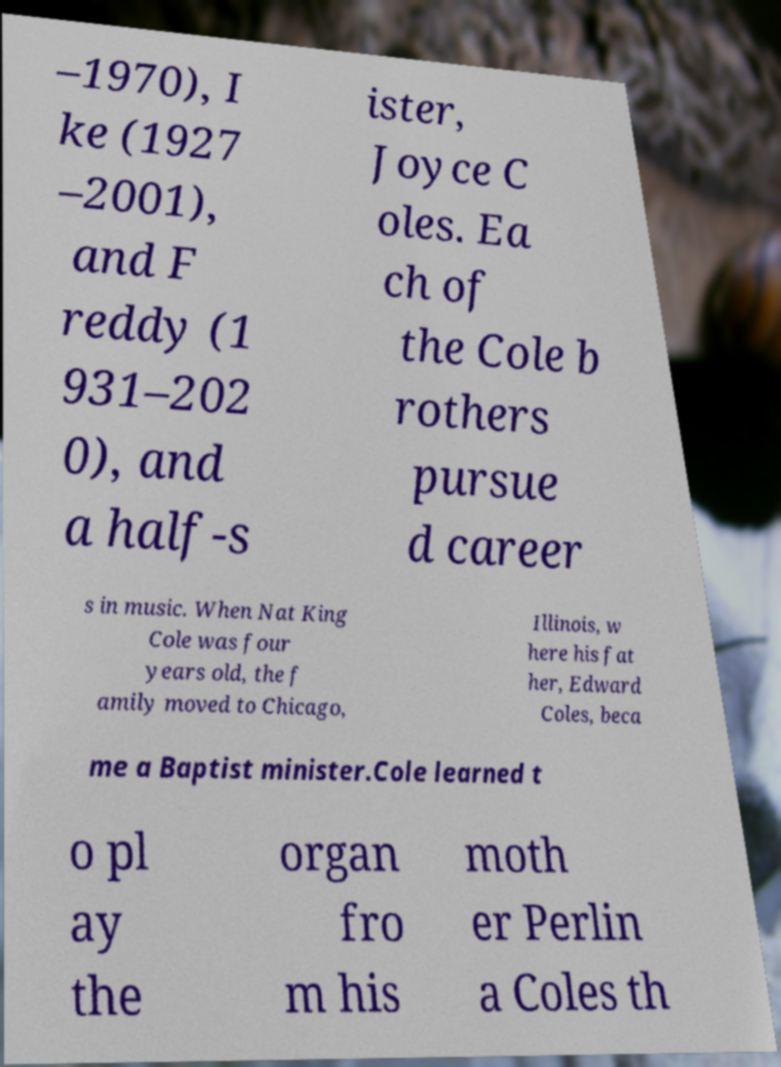Please identify and transcribe the text found in this image. –1970), I ke (1927 –2001), and F reddy (1 931–202 0), and a half-s ister, Joyce C oles. Ea ch of the Cole b rothers pursue d career s in music. When Nat King Cole was four years old, the f amily moved to Chicago, Illinois, w here his fat her, Edward Coles, beca me a Baptist minister.Cole learned t o pl ay the organ fro m his moth er Perlin a Coles th 